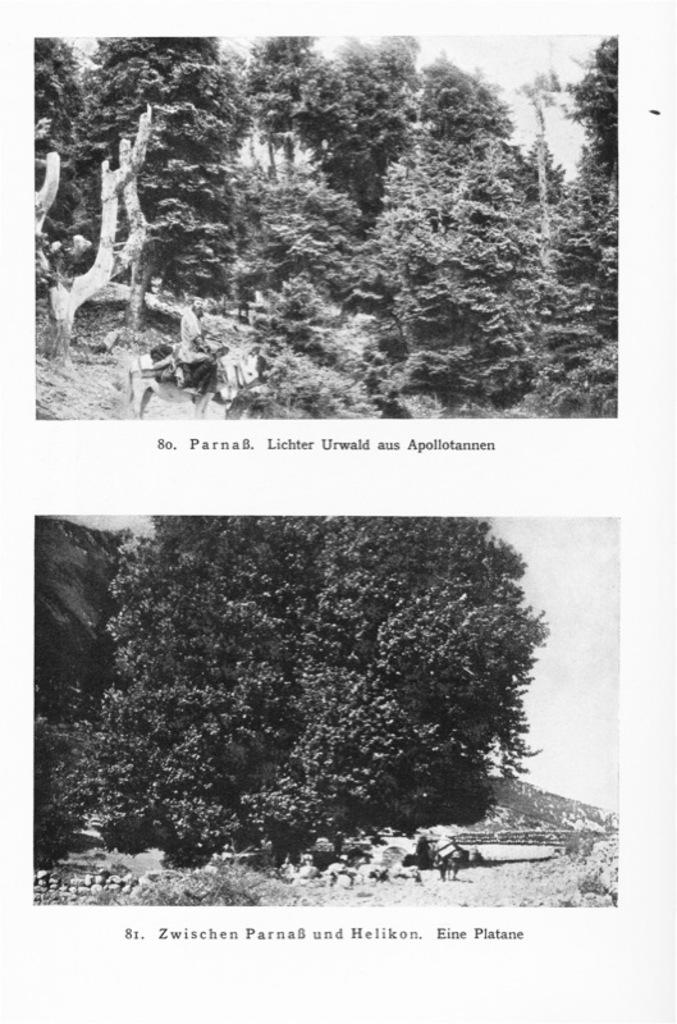What is the color scheme of the image? The image is black and white. What types of natural elements are depicted in the image? There are images of trees and the sky in the image. What living beings are shown in the image? There is an image of an animal and an image of a person in the image. Is there any text present in the image? Yes, there is text present in the image. What type of fish can be seen swimming in the image? There is no fish present in the image; it only contains images of trees, the sky, an animal, a person, and text. How many sheep are visible in the image? There are no sheep present in the image. 